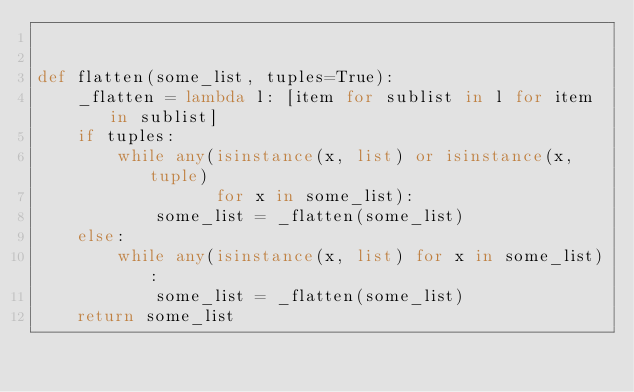<code> <loc_0><loc_0><loc_500><loc_500><_Python_>

def flatten(some_list, tuples=True):
    _flatten = lambda l: [item for sublist in l for item in sublist]
    if tuples:
        while any(isinstance(x, list) or isinstance(x, tuple)
                  for x in some_list):
            some_list = _flatten(some_list)
    else:
        while any(isinstance(x, list) for x in some_list):
            some_list = _flatten(some_list)
    return some_list

</code> 